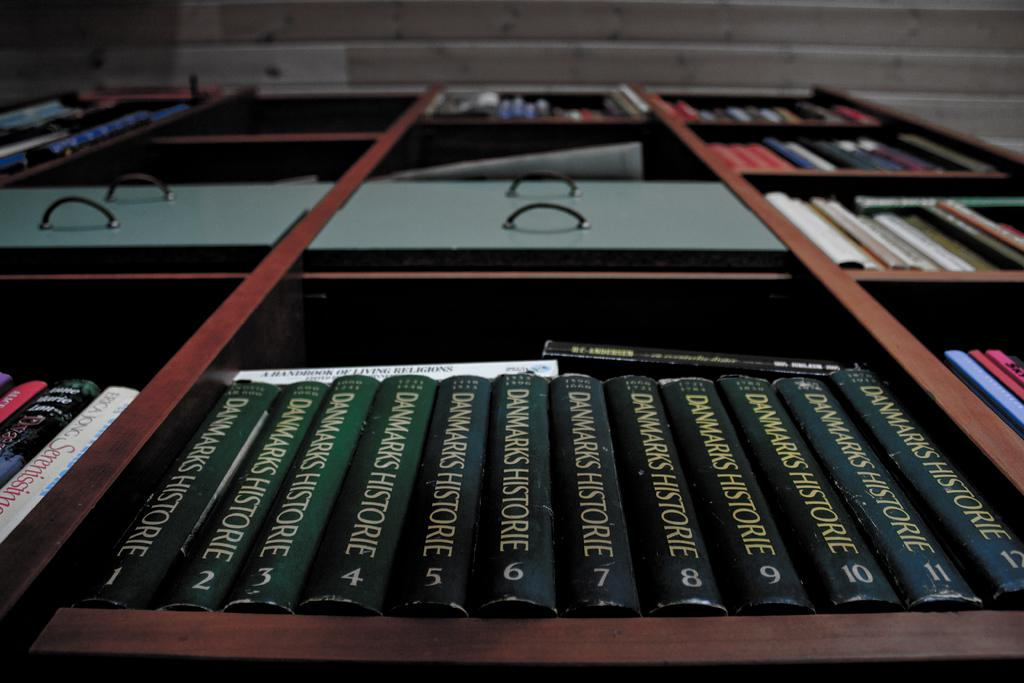<image>
Relay a brief, clear account of the picture shown. Twelve volumes of Dwarks Historie line a bookshelf, their green spines all alike. 